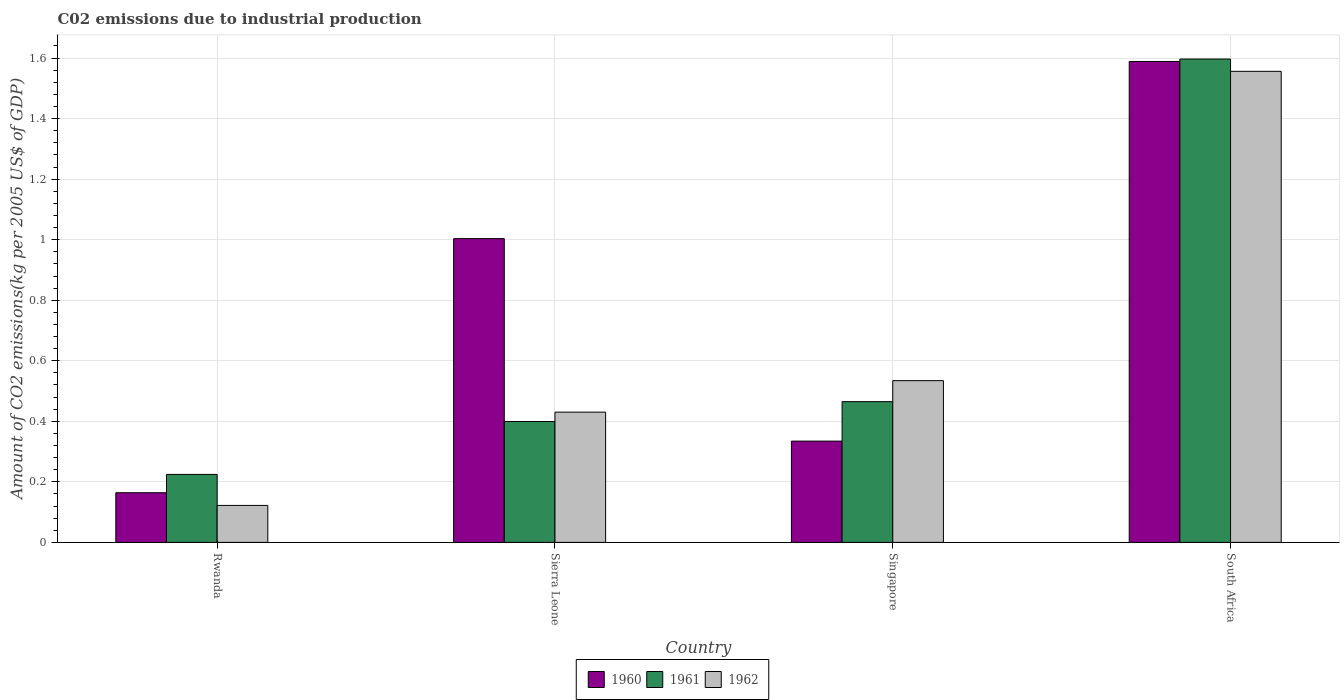How many different coloured bars are there?
Offer a terse response. 3. How many groups of bars are there?
Make the answer very short. 4. What is the label of the 2nd group of bars from the left?
Make the answer very short. Sierra Leone. In how many cases, is the number of bars for a given country not equal to the number of legend labels?
Provide a short and direct response. 0. What is the amount of CO2 emitted due to industrial production in 1960 in South Africa?
Your response must be concise. 1.59. Across all countries, what is the maximum amount of CO2 emitted due to industrial production in 1960?
Offer a terse response. 1.59. Across all countries, what is the minimum amount of CO2 emitted due to industrial production in 1961?
Ensure brevity in your answer.  0.22. In which country was the amount of CO2 emitted due to industrial production in 1960 maximum?
Your answer should be very brief. South Africa. In which country was the amount of CO2 emitted due to industrial production in 1961 minimum?
Provide a short and direct response. Rwanda. What is the total amount of CO2 emitted due to industrial production in 1961 in the graph?
Provide a succinct answer. 2.69. What is the difference between the amount of CO2 emitted due to industrial production in 1962 in Sierra Leone and that in South Africa?
Keep it short and to the point. -1.13. What is the difference between the amount of CO2 emitted due to industrial production in 1960 in Sierra Leone and the amount of CO2 emitted due to industrial production in 1962 in Singapore?
Give a very brief answer. 0.47. What is the average amount of CO2 emitted due to industrial production in 1960 per country?
Give a very brief answer. 0.77. What is the difference between the amount of CO2 emitted due to industrial production of/in 1960 and amount of CO2 emitted due to industrial production of/in 1962 in South Africa?
Provide a succinct answer. 0.03. In how many countries, is the amount of CO2 emitted due to industrial production in 1962 greater than 0.8400000000000001 kg?
Your response must be concise. 1. What is the ratio of the amount of CO2 emitted due to industrial production in 1962 in Singapore to that in South Africa?
Provide a succinct answer. 0.34. Is the amount of CO2 emitted due to industrial production in 1962 in Rwanda less than that in South Africa?
Give a very brief answer. Yes. What is the difference between the highest and the second highest amount of CO2 emitted due to industrial production in 1960?
Your answer should be very brief. -1.25. What is the difference between the highest and the lowest amount of CO2 emitted due to industrial production in 1961?
Provide a succinct answer. 1.37. What does the 1st bar from the left in Sierra Leone represents?
Your response must be concise. 1960. What does the 2nd bar from the right in Singapore represents?
Offer a terse response. 1961. Is it the case that in every country, the sum of the amount of CO2 emitted due to industrial production in 1961 and amount of CO2 emitted due to industrial production in 1960 is greater than the amount of CO2 emitted due to industrial production in 1962?
Provide a short and direct response. Yes. How many bars are there?
Provide a succinct answer. 12. Are the values on the major ticks of Y-axis written in scientific E-notation?
Ensure brevity in your answer.  No. Does the graph contain grids?
Make the answer very short. Yes. Where does the legend appear in the graph?
Give a very brief answer. Bottom center. How many legend labels are there?
Your answer should be very brief. 3. How are the legend labels stacked?
Provide a succinct answer. Horizontal. What is the title of the graph?
Offer a very short reply. C02 emissions due to industrial production. Does "1983" appear as one of the legend labels in the graph?
Your answer should be compact. No. What is the label or title of the Y-axis?
Offer a terse response. Amount of CO2 emissions(kg per 2005 US$ of GDP). What is the Amount of CO2 emissions(kg per 2005 US$ of GDP) in 1960 in Rwanda?
Provide a short and direct response. 0.16. What is the Amount of CO2 emissions(kg per 2005 US$ of GDP) in 1961 in Rwanda?
Offer a terse response. 0.22. What is the Amount of CO2 emissions(kg per 2005 US$ of GDP) of 1962 in Rwanda?
Your response must be concise. 0.12. What is the Amount of CO2 emissions(kg per 2005 US$ of GDP) in 1960 in Sierra Leone?
Your answer should be compact. 1. What is the Amount of CO2 emissions(kg per 2005 US$ of GDP) in 1961 in Sierra Leone?
Make the answer very short. 0.4. What is the Amount of CO2 emissions(kg per 2005 US$ of GDP) in 1962 in Sierra Leone?
Your answer should be very brief. 0.43. What is the Amount of CO2 emissions(kg per 2005 US$ of GDP) of 1960 in Singapore?
Offer a very short reply. 0.33. What is the Amount of CO2 emissions(kg per 2005 US$ of GDP) in 1961 in Singapore?
Your answer should be compact. 0.46. What is the Amount of CO2 emissions(kg per 2005 US$ of GDP) of 1962 in Singapore?
Offer a very short reply. 0.53. What is the Amount of CO2 emissions(kg per 2005 US$ of GDP) of 1960 in South Africa?
Offer a very short reply. 1.59. What is the Amount of CO2 emissions(kg per 2005 US$ of GDP) of 1961 in South Africa?
Make the answer very short. 1.6. What is the Amount of CO2 emissions(kg per 2005 US$ of GDP) of 1962 in South Africa?
Your response must be concise. 1.56. Across all countries, what is the maximum Amount of CO2 emissions(kg per 2005 US$ of GDP) of 1960?
Your answer should be compact. 1.59. Across all countries, what is the maximum Amount of CO2 emissions(kg per 2005 US$ of GDP) of 1961?
Make the answer very short. 1.6. Across all countries, what is the maximum Amount of CO2 emissions(kg per 2005 US$ of GDP) of 1962?
Your answer should be compact. 1.56. Across all countries, what is the minimum Amount of CO2 emissions(kg per 2005 US$ of GDP) in 1960?
Offer a very short reply. 0.16. Across all countries, what is the minimum Amount of CO2 emissions(kg per 2005 US$ of GDP) in 1961?
Your response must be concise. 0.22. Across all countries, what is the minimum Amount of CO2 emissions(kg per 2005 US$ of GDP) of 1962?
Your answer should be compact. 0.12. What is the total Amount of CO2 emissions(kg per 2005 US$ of GDP) of 1960 in the graph?
Provide a succinct answer. 3.09. What is the total Amount of CO2 emissions(kg per 2005 US$ of GDP) in 1961 in the graph?
Make the answer very short. 2.69. What is the total Amount of CO2 emissions(kg per 2005 US$ of GDP) of 1962 in the graph?
Offer a terse response. 2.64. What is the difference between the Amount of CO2 emissions(kg per 2005 US$ of GDP) in 1960 in Rwanda and that in Sierra Leone?
Your answer should be compact. -0.84. What is the difference between the Amount of CO2 emissions(kg per 2005 US$ of GDP) of 1961 in Rwanda and that in Sierra Leone?
Offer a terse response. -0.17. What is the difference between the Amount of CO2 emissions(kg per 2005 US$ of GDP) in 1962 in Rwanda and that in Sierra Leone?
Provide a succinct answer. -0.31. What is the difference between the Amount of CO2 emissions(kg per 2005 US$ of GDP) of 1960 in Rwanda and that in Singapore?
Offer a terse response. -0.17. What is the difference between the Amount of CO2 emissions(kg per 2005 US$ of GDP) in 1961 in Rwanda and that in Singapore?
Give a very brief answer. -0.24. What is the difference between the Amount of CO2 emissions(kg per 2005 US$ of GDP) of 1962 in Rwanda and that in Singapore?
Ensure brevity in your answer.  -0.41. What is the difference between the Amount of CO2 emissions(kg per 2005 US$ of GDP) in 1960 in Rwanda and that in South Africa?
Provide a short and direct response. -1.42. What is the difference between the Amount of CO2 emissions(kg per 2005 US$ of GDP) in 1961 in Rwanda and that in South Africa?
Provide a short and direct response. -1.37. What is the difference between the Amount of CO2 emissions(kg per 2005 US$ of GDP) in 1962 in Rwanda and that in South Africa?
Provide a succinct answer. -1.43. What is the difference between the Amount of CO2 emissions(kg per 2005 US$ of GDP) of 1960 in Sierra Leone and that in Singapore?
Your response must be concise. 0.67. What is the difference between the Amount of CO2 emissions(kg per 2005 US$ of GDP) of 1961 in Sierra Leone and that in Singapore?
Your response must be concise. -0.07. What is the difference between the Amount of CO2 emissions(kg per 2005 US$ of GDP) in 1962 in Sierra Leone and that in Singapore?
Provide a succinct answer. -0.1. What is the difference between the Amount of CO2 emissions(kg per 2005 US$ of GDP) of 1960 in Sierra Leone and that in South Africa?
Offer a very short reply. -0.59. What is the difference between the Amount of CO2 emissions(kg per 2005 US$ of GDP) of 1961 in Sierra Leone and that in South Africa?
Your response must be concise. -1.2. What is the difference between the Amount of CO2 emissions(kg per 2005 US$ of GDP) of 1962 in Sierra Leone and that in South Africa?
Your response must be concise. -1.13. What is the difference between the Amount of CO2 emissions(kg per 2005 US$ of GDP) in 1960 in Singapore and that in South Africa?
Provide a short and direct response. -1.25. What is the difference between the Amount of CO2 emissions(kg per 2005 US$ of GDP) in 1961 in Singapore and that in South Africa?
Offer a terse response. -1.13. What is the difference between the Amount of CO2 emissions(kg per 2005 US$ of GDP) of 1962 in Singapore and that in South Africa?
Give a very brief answer. -1.02. What is the difference between the Amount of CO2 emissions(kg per 2005 US$ of GDP) of 1960 in Rwanda and the Amount of CO2 emissions(kg per 2005 US$ of GDP) of 1961 in Sierra Leone?
Offer a very short reply. -0.24. What is the difference between the Amount of CO2 emissions(kg per 2005 US$ of GDP) in 1960 in Rwanda and the Amount of CO2 emissions(kg per 2005 US$ of GDP) in 1962 in Sierra Leone?
Your answer should be compact. -0.27. What is the difference between the Amount of CO2 emissions(kg per 2005 US$ of GDP) in 1961 in Rwanda and the Amount of CO2 emissions(kg per 2005 US$ of GDP) in 1962 in Sierra Leone?
Offer a very short reply. -0.21. What is the difference between the Amount of CO2 emissions(kg per 2005 US$ of GDP) of 1960 in Rwanda and the Amount of CO2 emissions(kg per 2005 US$ of GDP) of 1961 in Singapore?
Provide a short and direct response. -0.3. What is the difference between the Amount of CO2 emissions(kg per 2005 US$ of GDP) of 1960 in Rwanda and the Amount of CO2 emissions(kg per 2005 US$ of GDP) of 1962 in Singapore?
Make the answer very short. -0.37. What is the difference between the Amount of CO2 emissions(kg per 2005 US$ of GDP) in 1961 in Rwanda and the Amount of CO2 emissions(kg per 2005 US$ of GDP) in 1962 in Singapore?
Offer a terse response. -0.31. What is the difference between the Amount of CO2 emissions(kg per 2005 US$ of GDP) of 1960 in Rwanda and the Amount of CO2 emissions(kg per 2005 US$ of GDP) of 1961 in South Africa?
Keep it short and to the point. -1.43. What is the difference between the Amount of CO2 emissions(kg per 2005 US$ of GDP) of 1960 in Rwanda and the Amount of CO2 emissions(kg per 2005 US$ of GDP) of 1962 in South Africa?
Your answer should be very brief. -1.39. What is the difference between the Amount of CO2 emissions(kg per 2005 US$ of GDP) of 1961 in Rwanda and the Amount of CO2 emissions(kg per 2005 US$ of GDP) of 1962 in South Africa?
Make the answer very short. -1.33. What is the difference between the Amount of CO2 emissions(kg per 2005 US$ of GDP) of 1960 in Sierra Leone and the Amount of CO2 emissions(kg per 2005 US$ of GDP) of 1961 in Singapore?
Offer a very short reply. 0.54. What is the difference between the Amount of CO2 emissions(kg per 2005 US$ of GDP) in 1960 in Sierra Leone and the Amount of CO2 emissions(kg per 2005 US$ of GDP) in 1962 in Singapore?
Offer a terse response. 0.47. What is the difference between the Amount of CO2 emissions(kg per 2005 US$ of GDP) in 1961 in Sierra Leone and the Amount of CO2 emissions(kg per 2005 US$ of GDP) in 1962 in Singapore?
Provide a succinct answer. -0.14. What is the difference between the Amount of CO2 emissions(kg per 2005 US$ of GDP) of 1960 in Sierra Leone and the Amount of CO2 emissions(kg per 2005 US$ of GDP) of 1961 in South Africa?
Offer a very short reply. -0.59. What is the difference between the Amount of CO2 emissions(kg per 2005 US$ of GDP) of 1960 in Sierra Leone and the Amount of CO2 emissions(kg per 2005 US$ of GDP) of 1962 in South Africa?
Make the answer very short. -0.55. What is the difference between the Amount of CO2 emissions(kg per 2005 US$ of GDP) in 1961 in Sierra Leone and the Amount of CO2 emissions(kg per 2005 US$ of GDP) in 1962 in South Africa?
Offer a very short reply. -1.16. What is the difference between the Amount of CO2 emissions(kg per 2005 US$ of GDP) of 1960 in Singapore and the Amount of CO2 emissions(kg per 2005 US$ of GDP) of 1961 in South Africa?
Ensure brevity in your answer.  -1.26. What is the difference between the Amount of CO2 emissions(kg per 2005 US$ of GDP) of 1960 in Singapore and the Amount of CO2 emissions(kg per 2005 US$ of GDP) of 1962 in South Africa?
Provide a succinct answer. -1.22. What is the difference between the Amount of CO2 emissions(kg per 2005 US$ of GDP) of 1961 in Singapore and the Amount of CO2 emissions(kg per 2005 US$ of GDP) of 1962 in South Africa?
Give a very brief answer. -1.09. What is the average Amount of CO2 emissions(kg per 2005 US$ of GDP) of 1960 per country?
Keep it short and to the point. 0.77. What is the average Amount of CO2 emissions(kg per 2005 US$ of GDP) in 1961 per country?
Provide a short and direct response. 0.67. What is the average Amount of CO2 emissions(kg per 2005 US$ of GDP) of 1962 per country?
Your response must be concise. 0.66. What is the difference between the Amount of CO2 emissions(kg per 2005 US$ of GDP) in 1960 and Amount of CO2 emissions(kg per 2005 US$ of GDP) in 1961 in Rwanda?
Offer a terse response. -0.06. What is the difference between the Amount of CO2 emissions(kg per 2005 US$ of GDP) of 1960 and Amount of CO2 emissions(kg per 2005 US$ of GDP) of 1962 in Rwanda?
Your answer should be very brief. 0.04. What is the difference between the Amount of CO2 emissions(kg per 2005 US$ of GDP) in 1961 and Amount of CO2 emissions(kg per 2005 US$ of GDP) in 1962 in Rwanda?
Ensure brevity in your answer.  0.1. What is the difference between the Amount of CO2 emissions(kg per 2005 US$ of GDP) of 1960 and Amount of CO2 emissions(kg per 2005 US$ of GDP) of 1961 in Sierra Leone?
Your answer should be compact. 0.6. What is the difference between the Amount of CO2 emissions(kg per 2005 US$ of GDP) in 1960 and Amount of CO2 emissions(kg per 2005 US$ of GDP) in 1962 in Sierra Leone?
Offer a terse response. 0.57. What is the difference between the Amount of CO2 emissions(kg per 2005 US$ of GDP) of 1961 and Amount of CO2 emissions(kg per 2005 US$ of GDP) of 1962 in Sierra Leone?
Your response must be concise. -0.03. What is the difference between the Amount of CO2 emissions(kg per 2005 US$ of GDP) in 1960 and Amount of CO2 emissions(kg per 2005 US$ of GDP) in 1961 in Singapore?
Provide a short and direct response. -0.13. What is the difference between the Amount of CO2 emissions(kg per 2005 US$ of GDP) of 1960 and Amount of CO2 emissions(kg per 2005 US$ of GDP) of 1962 in Singapore?
Provide a short and direct response. -0.2. What is the difference between the Amount of CO2 emissions(kg per 2005 US$ of GDP) in 1961 and Amount of CO2 emissions(kg per 2005 US$ of GDP) in 1962 in Singapore?
Ensure brevity in your answer.  -0.07. What is the difference between the Amount of CO2 emissions(kg per 2005 US$ of GDP) in 1960 and Amount of CO2 emissions(kg per 2005 US$ of GDP) in 1961 in South Africa?
Offer a very short reply. -0.01. What is the difference between the Amount of CO2 emissions(kg per 2005 US$ of GDP) of 1960 and Amount of CO2 emissions(kg per 2005 US$ of GDP) of 1962 in South Africa?
Offer a terse response. 0.03. What is the difference between the Amount of CO2 emissions(kg per 2005 US$ of GDP) of 1961 and Amount of CO2 emissions(kg per 2005 US$ of GDP) of 1962 in South Africa?
Your answer should be very brief. 0.04. What is the ratio of the Amount of CO2 emissions(kg per 2005 US$ of GDP) of 1960 in Rwanda to that in Sierra Leone?
Your response must be concise. 0.16. What is the ratio of the Amount of CO2 emissions(kg per 2005 US$ of GDP) in 1961 in Rwanda to that in Sierra Leone?
Make the answer very short. 0.56. What is the ratio of the Amount of CO2 emissions(kg per 2005 US$ of GDP) in 1962 in Rwanda to that in Sierra Leone?
Offer a very short reply. 0.28. What is the ratio of the Amount of CO2 emissions(kg per 2005 US$ of GDP) in 1960 in Rwanda to that in Singapore?
Your response must be concise. 0.49. What is the ratio of the Amount of CO2 emissions(kg per 2005 US$ of GDP) in 1961 in Rwanda to that in Singapore?
Give a very brief answer. 0.48. What is the ratio of the Amount of CO2 emissions(kg per 2005 US$ of GDP) in 1962 in Rwanda to that in Singapore?
Keep it short and to the point. 0.23. What is the ratio of the Amount of CO2 emissions(kg per 2005 US$ of GDP) in 1960 in Rwanda to that in South Africa?
Offer a terse response. 0.1. What is the ratio of the Amount of CO2 emissions(kg per 2005 US$ of GDP) in 1961 in Rwanda to that in South Africa?
Provide a short and direct response. 0.14. What is the ratio of the Amount of CO2 emissions(kg per 2005 US$ of GDP) of 1962 in Rwanda to that in South Africa?
Keep it short and to the point. 0.08. What is the ratio of the Amount of CO2 emissions(kg per 2005 US$ of GDP) in 1960 in Sierra Leone to that in Singapore?
Provide a short and direct response. 3. What is the ratio of the Amount of CO2 emissions(kg per 2005 US$ of GDP) in 1961 in Sierra Leone to that in Singapore?
Keep it short and to the point. 0.86. What is the ratio of the Amount of CO2 emissions(kg per 2005 US$ of GDP) of 1962 in Sierra Leone to that in Singapore?
Make the answer very short. 0.81. What is the ratio of the Amount of CO2 emissions(kg per 2005 US$ of GDP) of 1960 in Sierra Leone to that in South Africa?
Your answer should be very brief. 0.63. What is the ratio of the Amount of CO2 emissions(kg per 2005 US$ of GDP) of 1961 in Sierra Leone to that in South Africa?
Keep it short and to the point. 0.25. What is the ratio of the Amount of CO2 emissions(kg per 2005 US$ of GDP) in 1962 in Sierra Leone to that in South Africa?
Ensure brevity in your answer.  0.28. What is the ratio of the Amount of CO2 emissions(kg per 2005 US$ of GDP) of 1960 in Singapore to that in South Africa?
Your answer should be very brief. 0.21. What is the ratio of the Amount of CO2 emissions(kg per 2005 US$ of GDP) of 1961 in Singapore to that in South Africa?
Ensure brevity in your answer.  0.29. What is the ratio of the Amount of CO2 emissions(kg per 2005 US$ of GDP) in 1962 in Singapore to that in South Africa?
Offer a terse response. 0.34. What is the difference between the highest and the second highest Amount of CO2 emissions(kg per 2005 US$ of GDP) in 1960?
Your answer should be very brief. 0.59. What is the difference between the highest and the second highest Amount of CO2 emissions(kg per 2005 US$ of GDP) in 1961?
Your response must be concise. 1.13. What is the difference between the highest and the second highest Amount of CO2 emissions(kg per 2005 US$ of GDP) of 1962?
Provide a succinct answer. 1.02. What is the difference between the highest and the lowest Amount of CO2 emissions(kg per 2005 US$ of GDP) in 1960?
Provide a succinct answer. 1.42. What is the difference between the highest and the lowest Amount of CO2 emissions(kg per 2005 US$ of GDP) in 1961?
Your response must be concise. 1.37. What is the difference between the highest and the lowest Amount of CO2 emissions(kg per 2005 US$ of GDP) in 1962?
Give a very brief answer. 1.43. 